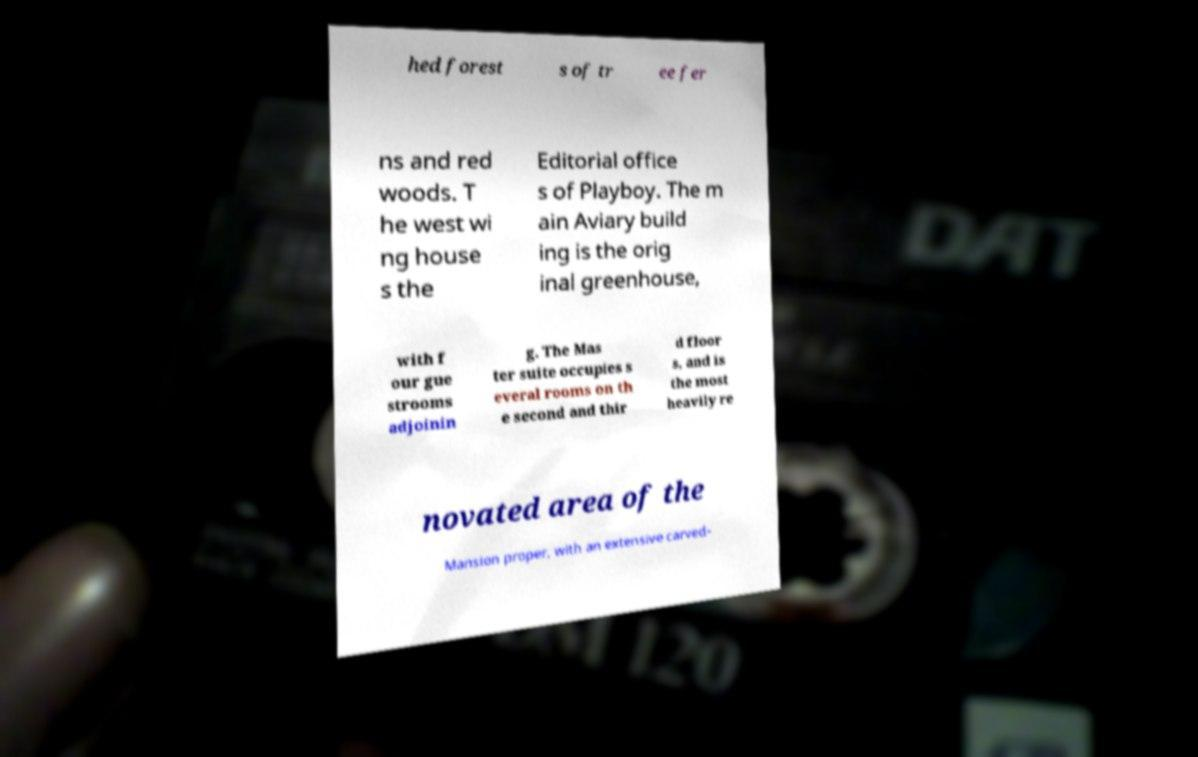Please read and relay the text visible in this image. What does it say? hed forest s of tr ee fer ns and red woods. T he west wi ng house s the Editorial office s of Playboy. The m ain Aviary build ing is the orig inal greenhouse, with f our gue strooms adjoinin g. The Mas ter suite occupies s everal rooms on th e second and thir d floor s, and is the most heavily re novated area of the Mansion proper, with an extensive carved- 